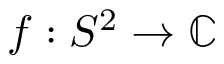Convert formula to latex. <formula><loc_0><loc_0><loc_500><loc_500>f \colon S ^ { 2 } \to \mathbb { C }</formula> 